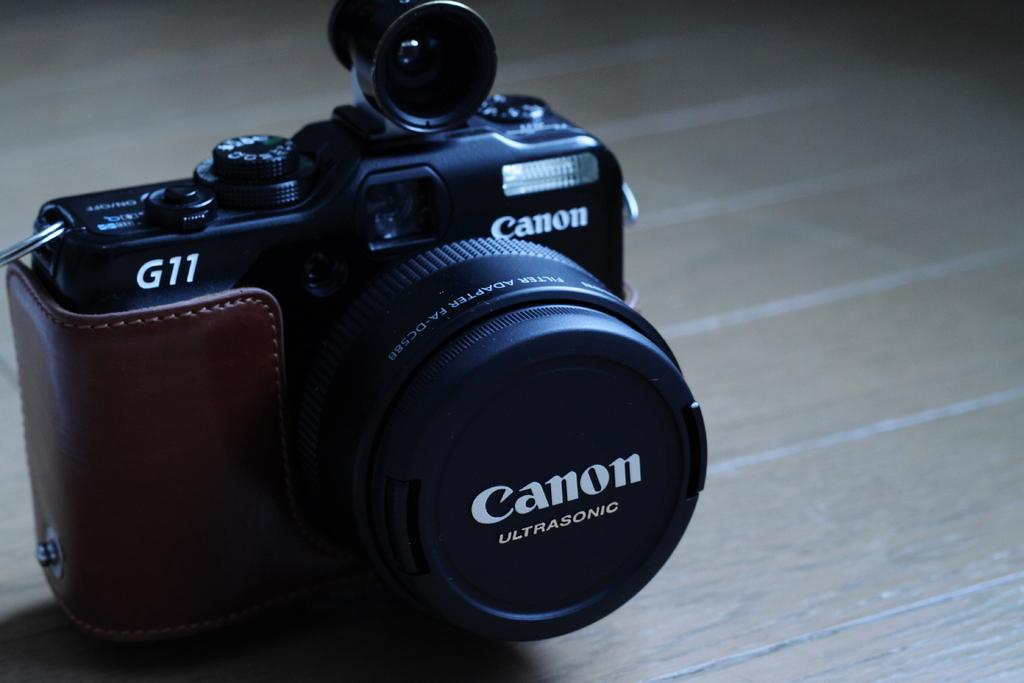What type of camera is visible in the image? There is a black color canon camera in the image. Where is the camera placed in the image? The camera is placed on a wooden table top. How many sheep are present in the image? There are no sheep present in the image; it features a black color canon camera placed on a wooden table top. What type of headwear is the sheep wearing in the image? There are no sheep present in the image, so it is not possible to determine what type of headwear they might be wearing. 